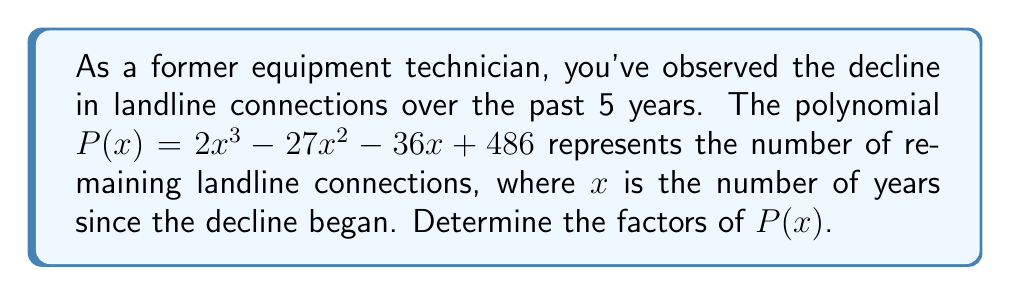Solve this math problem. Let's approach this step-by-step:

1) First, we need to check if there are any common factors. In this case, there are no common factors for all terms.

2) Next, we can try to guess one of the factors. Since the constant term is 486, we can look for factors of 486 that might be roots of the polynomial. Some potential factors are ±1, ±2, ±3, ±6, ±9, ±18, ±27, ±54, ±81, ±162, ±243, ±486.

3) Using the rational root theorem, we can test these potential roots. After testing, we find that 9 is a root of the polynomial.

4) So, $(x - 9)$ is a factor of $P(x)$. We can use polynomial long division to find the other factor:

   $$\frac{2x^3 - 27x^2 - 36x + 486}{x - 9} = 2x^2 + 9x - 54$$

5) Therefore, $P(x) = (x - 9)(2x^2 + 9x - 54)$

6) Now, we need to factor the quadratic term $2x^2 + 9x - 54$. We can use the quadratic formula or factoring by grouping.

7) Using factoring by grouping:
   $2x^2 + 9x - 54 = (2x - 6)(x + 9)$

8) Therefore, the complete factorization is:
   $P(x) = (x - 9)(2x - 6)(x + 9)$

9) We can further simplify $(2x - 6)$ to $2(x - 3)$

Thus, the final factorization is:
$P(x) = (x - 9)(x + 9)2(x - 3)$
Answer: $P(x) = 2(x - 9)(x + 9)(x - 3)$ 